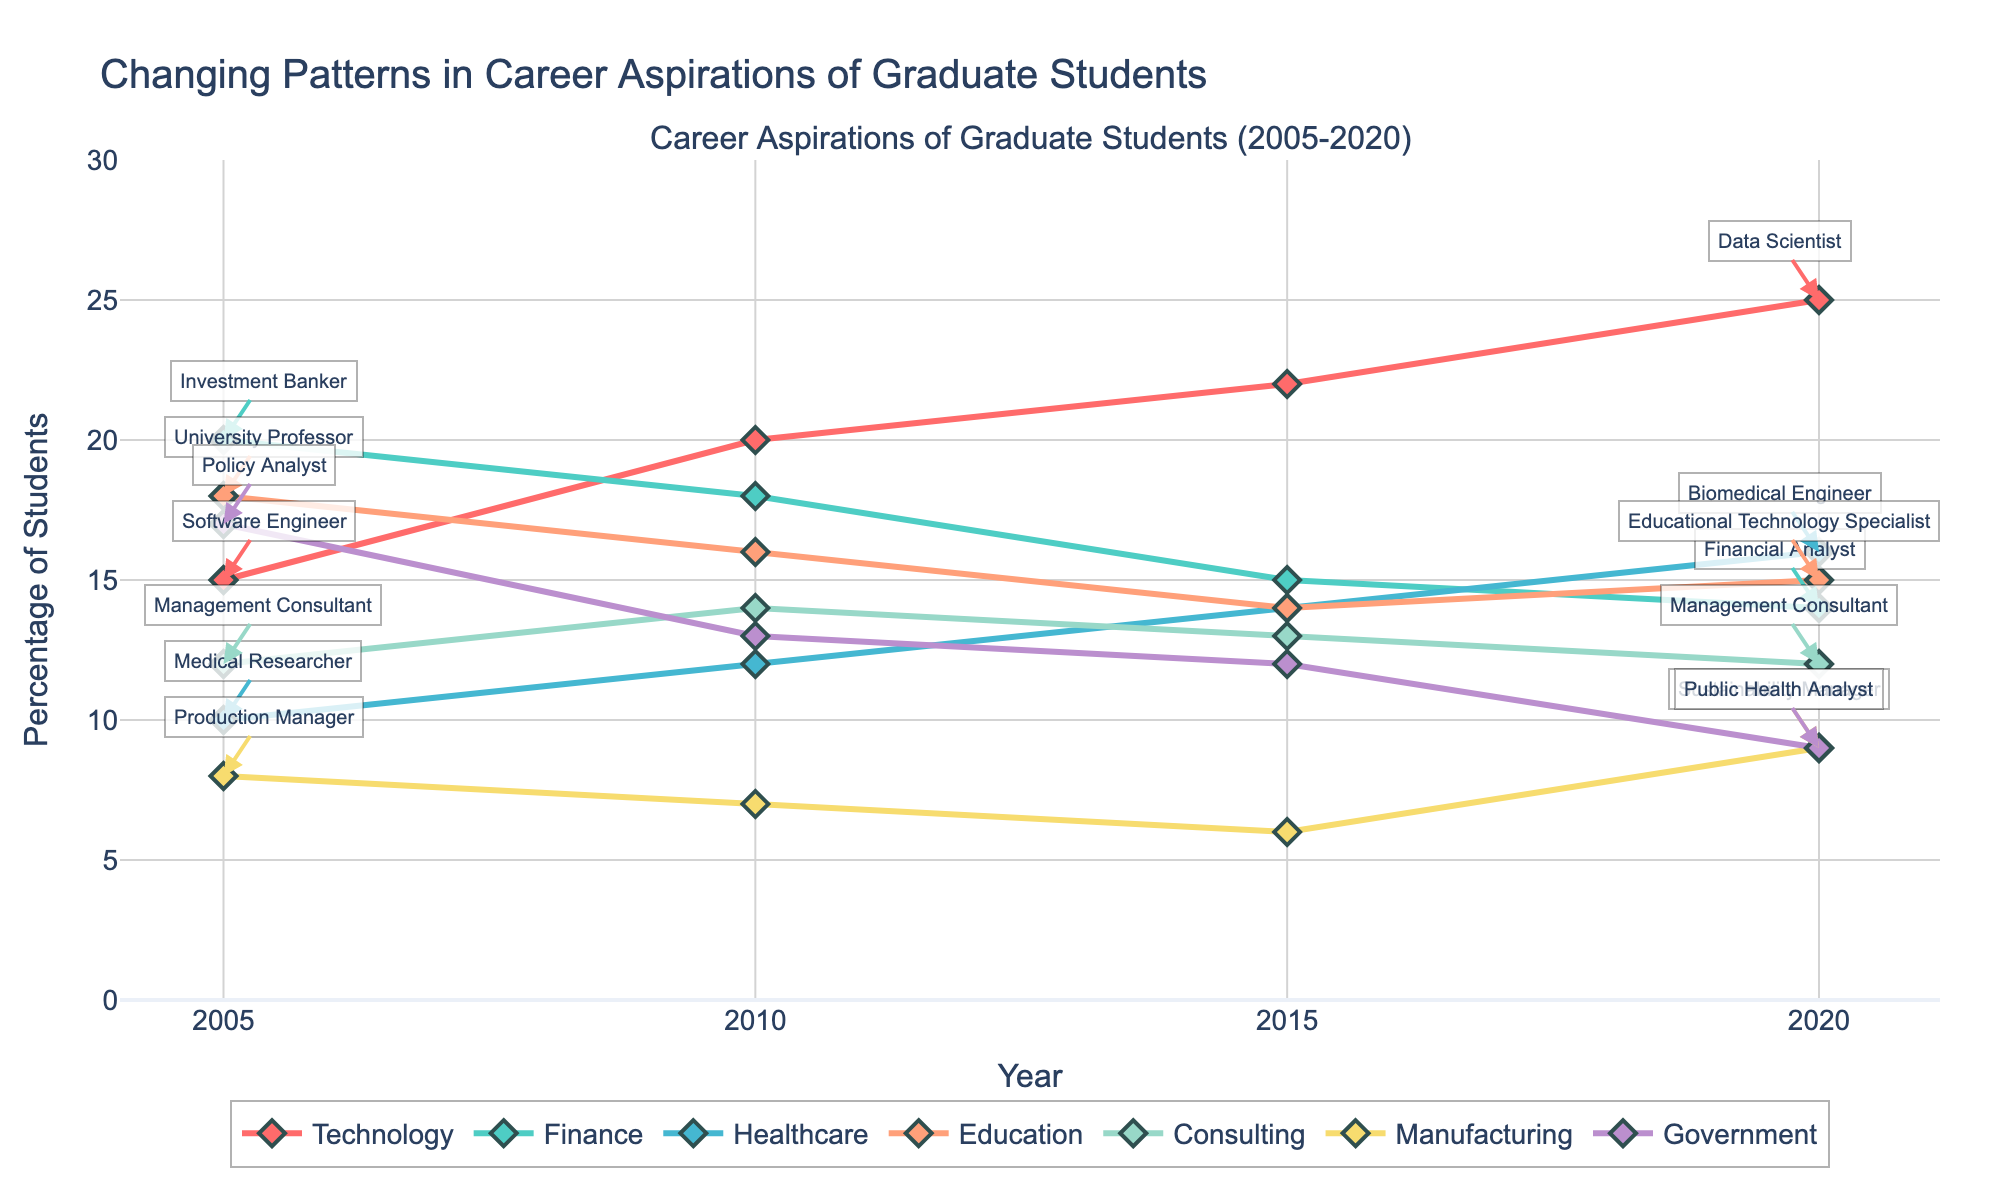What is the title of the plot? The title is displayed at the top center of the figure. It reads 'Changing Patterns in Career Aspirations of Graduate Students'.
Answer: Changing Patterns in Career Aspirations of Graduate Students Which industry has the highest percentage in 2020? The lines are labeled by different colors representing each industry. The highest percentage in 2020 is represented by the industry with the topmost point on the y-axis.
Answer: Technology How did the percentage of students aspiring to be Software Engineers change from 2005 to 2020? Look at the percentage for Software Engineers in the years 2005 and 2010, then note that the role changed to Data Scientist in subsequent years but pertains to the same industry (Technology). Compare the percentages for each selected year.
Answer: Increased Which roles were annotated in 2005 and 2020? The annotations are visible on the figure near the specific data points for the years 2005 and 2020.
Answer: Software Engineer, Investment Banker, Medical Researcher, University Professor, Management Consultant, Production Manager, Policy Analyst; Data Scientist, Financial Analyst, Biomedical Engineer, Educational Technology Specialist, Management Consultant, Sustainability Manager, Public Health Analyst Did the interest in being a University Professor increase or decrease from 2005 to 2020? Follow the line marked for Education. Observe the percentage changes between 2005 (starting point) and 2020 (ending point).
Answer: Decrease What was the percentage difference between students aspiring to be Data Scientists and Financial Analysts in 2020? Find the point on the plot for Data Scientists and Financial Analysts in 2020, subtract the percentage of Financial Analysts from Data Scientists.
Answer: 11 In which year did the number of students aspiring to be Investment Bankers peak? Trace the percentage line for Finance. Identify the year with the highest percentage.
Answer: 2005 What industry showed the greatest decrease in student interest from 2005 to 2020? Observe all percentage lines from 2005 to 2020 and identify which line dropped the most from its highest point in 2005 to its lowest point in 2020.
Answer: Government How did interest in healthcare roles change over the years? Follow the line for Healthcare across the timeline from 2005 to 2020 and describe the overall trend.
Answer: Increased Which industry remained relatively stable over the years? Look for the line that shows the least fluctuation from 2005 to 2020.
Answer: Consulting 